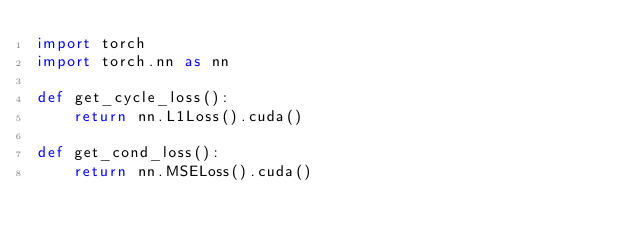<code> <loc_0><loc_0><loc_500><loc_500><_Python_>import torch
import torch.nn as nn

def get_cycle_loss():
    return nn.L1Loss().cuda()

def get_cond_loss():
    return nn.MSELoss().cuda()


</code> 